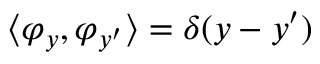Convert formula to latex. <formula><loc_0><loc_0><loc_500><loc_500>\langle \varphi _ { y } , \varphi _ { y ^ { \prime } } \rangle = \delta ( y - y ^ { \prime } )</formula> 